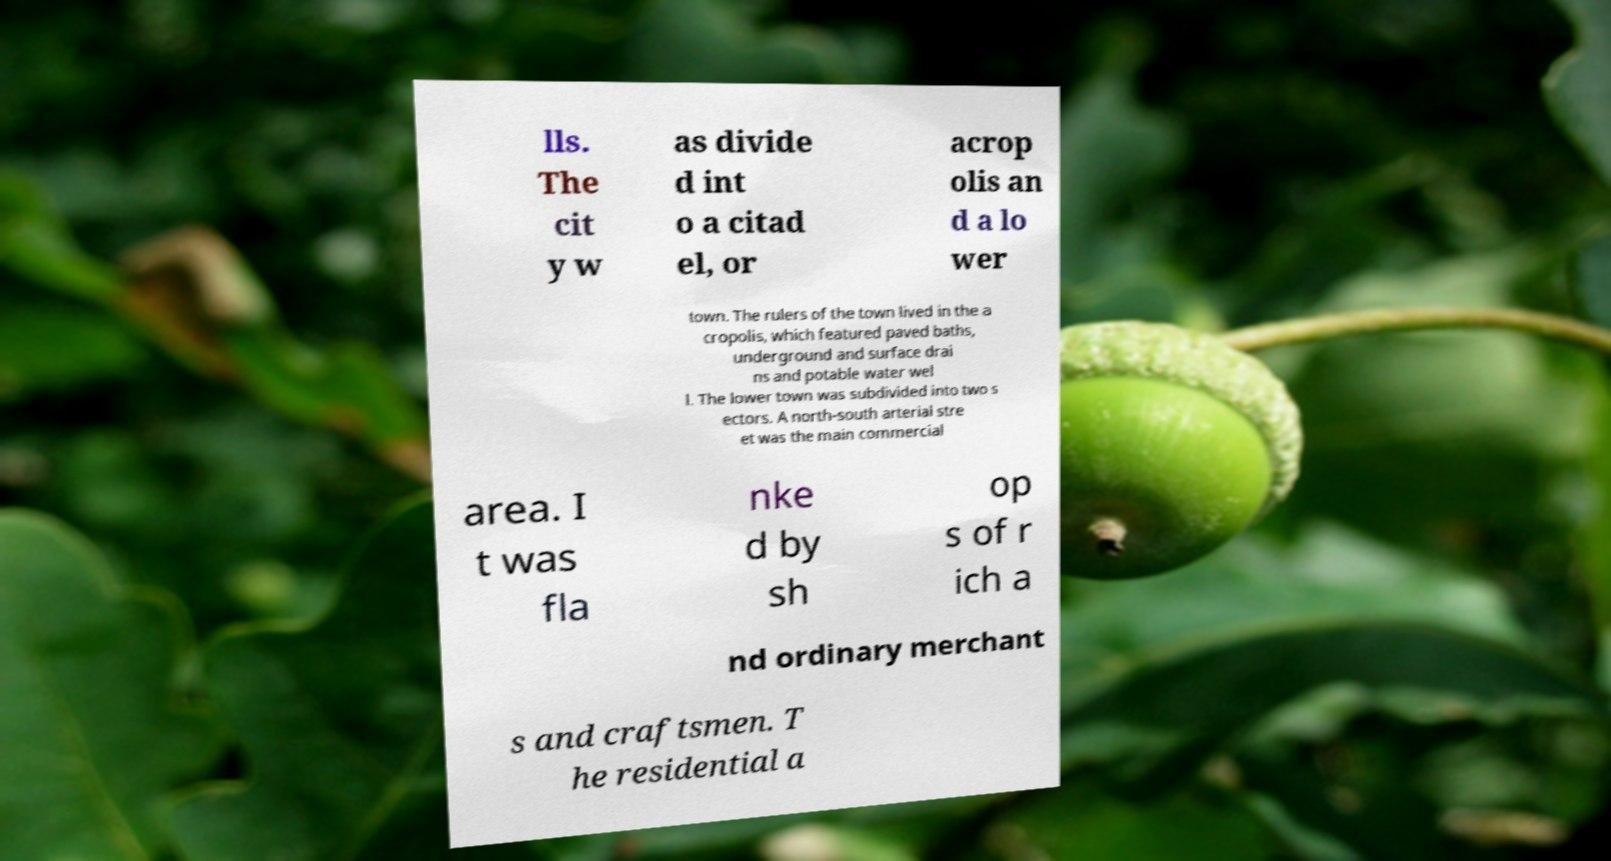Please identify and transcribe the text found in this image. lls. The cit y w as divide d int o a citad el, or acrop olis an d a lo wer town. The rulers of the town lived in the a cropolis, which featured paved baths, underground and surface drai ns and potable water wel l. The lower town was subdivided into two s ectors. A north-south arterial stre et was the main commercial area. I t was fla nke d by sh op s of r ich a nd ordinary merchant s and craftsmen. T he residential a 